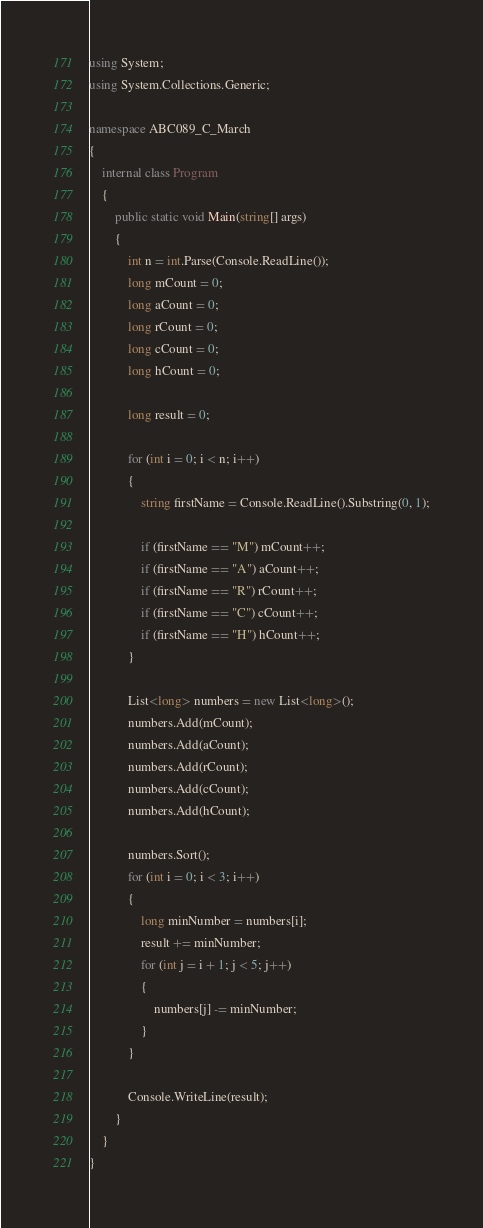Convert code to text. <code><loc_0><loc_0><loc_500><loc_500><_C#_>using System;
using System.Collections.Generic;

namespace ABC089_C_March
{
	internal class Program
	{
		public static void Main(string[] args)
		{
			int n = int.Parse(Console.ReadLine());
			long mCount = 0;
			long aCount = 0;
			long rCount = 0;
			long cCount = 0;
			long hCount = 0;

			long result = 0;

			for (int i = 0; i < n; i++)
			{
				string firstName = Console.ReadLine().Substring(0, 1);

				if (firstName == "M") mCount++;
				if (firstName == "A") aCount++;
				if (firstName == "R") rCount++;
				if (firstName == "C") cCount++;
				if (firstName == "H") hCount++;
			}
			
			List<long> numbers = new List<long>();
			numbers.Add(mCount);
			numbers.Add(aCount);
			numbers.Add(rCount);
			numbers.Add(cCount);
			numbers.Add(hCount);

			numbers.Sort();
			for (int i = 0; i < 3; i++)
			{
				long minNumber = numbers[i];
				result += minNumber;
				for (int j = i + 1; j < 5; j++)
				{
					numbers[j] -= minNumber;
				}
			}
			
			Console.WriteLine(result);
		}
	}
}
</code> 